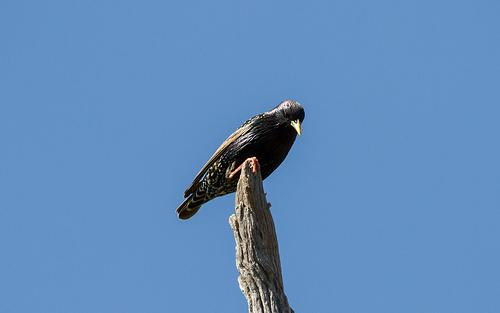Indicate the color and condition of the tree branch or stick. The stick is brown, rough, and has a dry texture with deep lines. What details can you observe about the bird's foot? The bird's foot is orange, bent over the wood, and its claws are digging into the side of the wood. Count the number of visible body parts of the bird and list them. Seven visible body parts: head, beak, foot, tail, feathers, wing, and belly. Provide a short narrative of the scene in the image. A black European starling with a yellow beak is perched on a rough, brown wooden post. The sky behind the bird is a clear cloudless blue. What is the condition of the wooden post the bird is sitting on? The wooden post is dry and grey with deep lines. Identify the number of birds and their species. There is one bird, a black European starling. Can you describe the appearance of the bird's beak? The bird's beak is triangular, yellow, and facing down. Tell me about the overall sentiment or mood conveyed by the image. The image conveys a peaceful and serene mood, with a beautiful black bird perched on a rough wooden post against a clear blue sky. Explain the action of the bird in the image. The bird is sitting on a wooden post. What is the dominant color in the sky? The dominant color in the sky is blue. 